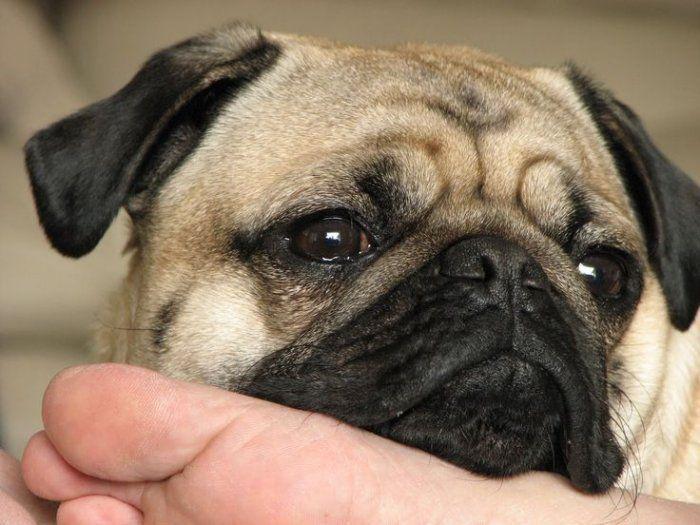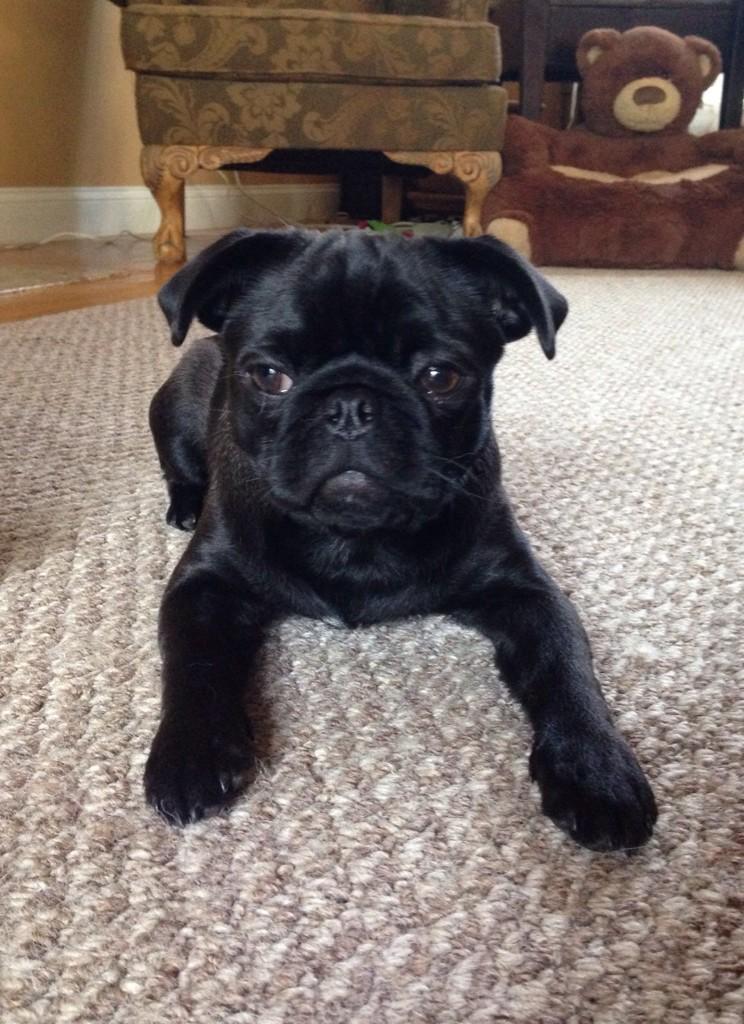The first image is the image on the left, the second image is the image on the right. Considering the images on both sides, is "One dog is wearing a dog collar." valid? Answer yes or no. No. The first image is the image on the left, the second image is the image on the right. For the images shown, is this caption "The pug in the right image is posed with head and body facing forward, and with his front paws extended and farther apart than its body width." true? Answer yes or no. Yes. 